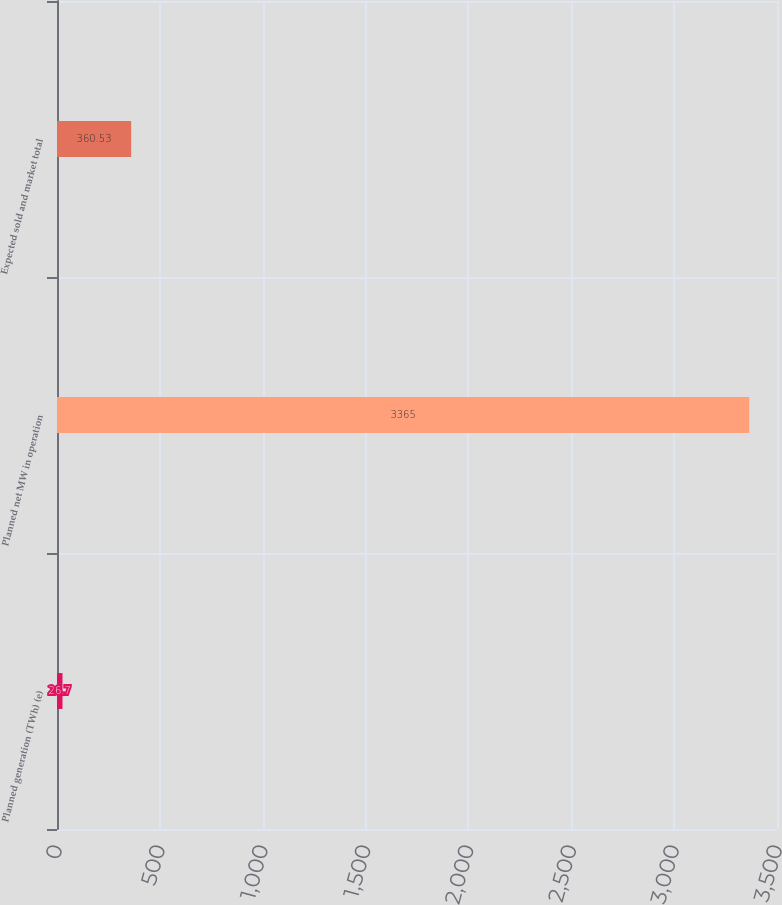Convert chart to OTSL. <chart><loc_0><loc_0><loc_500><loc_500><bar_chart><fcel>Planned generation (TWh) (e)<fcel>Planned net MW in operation<fcel>Expected sold and market total<nl><fcel>26.7<fcel>3365<fcel>360.53<nl></chart> 